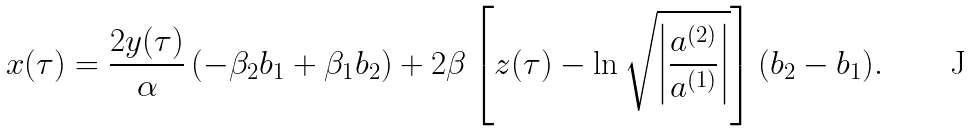<formula> <loc_0><loc_0><loc_500><loc_500>x ( \tau ) = \frac { 2 y ( \tau ) } { \alpha } \left ( - \beta _ { 2 } b _ { 1 } + \beta _ { 1 } b _ { 2 } \right ) + 2 \beta \left [ z ( \tau ) - \ln { \sqrt { \left | \frac { a ^ { ( 2 ) } } { a ^ { ( 1 ) } } \right | } } \right ] ( b _ { 2 } - b _ { 1 } ) .</formula> 